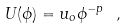<formula> <loc_0><loc_0><loc_500><loc_500>U ( \phi ) = u _ { o } \phi ^ { - p } \ ,</formula> 